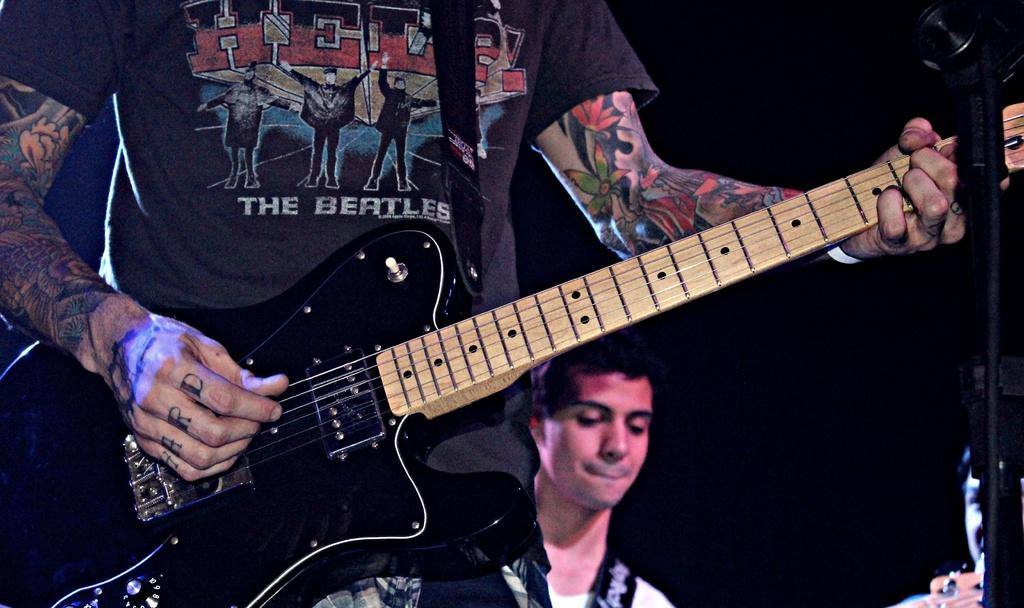What is the person in the image holding? The person in the image is holding a guitar. Can you describe the background of the image? There is a man in the background of the image. What type of wood is the person learning to adjust in the image? There is no wood or adjustment activity present in the image; it features a person holding a guitar and a man in the background. 